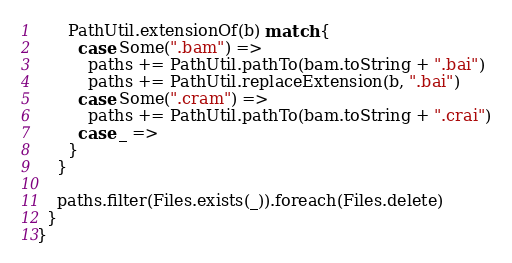Convert code to text. <code><loc_0><loc_0><loc_500><loc_500><_Scala_>      PathUtil.extensionOf(b) match {
        case Some(".bam") =>
          paths += PathUtil.pathTo(bam.toString + ".bai")
          paths += PathUtil.replaceExtension(b, ".bai")
        case Some(".cram") =>
          paths += PathUtil.pathTo(bam.toString + ".crai")
        case _ =>
      }
    }

    paths.filter(Files.exists(_)).foreach(Files.delete)
  }
}
</code> 